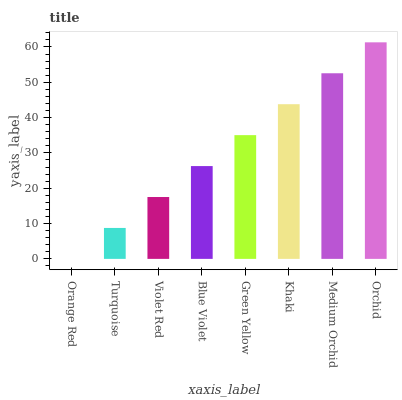Is Orange Red the minimum?
Answer yes or no. Yes. Is Orchid the maximum?
Answer yes or no. Yes. Is Turquoise the minimum?
Answer yes or no. No. Is Turquoise the maximum?
Answer yes or no. No. Is Turquoise greater than Orange Red?
Answer yes or no. Yes. Is Orange Red less than Turquoise?
Answer yes or no. Yes. Is Orange Red greater than Turquoise?
Answer yes or no. No. Is Turquoise less than Orange Red?
Answer yes or no. No. Is Green Yellow the high median?
Answer yes or no. Yes. Is Blue Violet the low median?
Answer yes or no. Yes. Is Orange Red the high median?
Answer yes or no. No. Is Turquoise the low median?
Answer yes or no. No. 